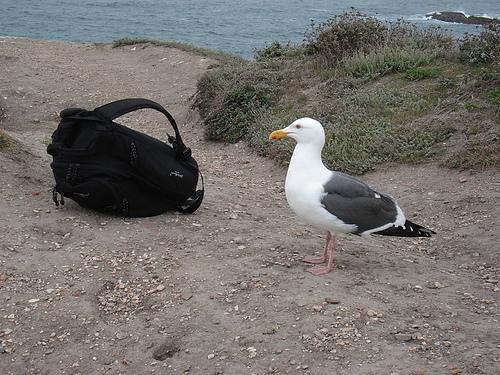How many birds are shown?
Quick response, please. 1. What do the feet of this particular birds have that others do not?
Short answer required. Webbed. What is the seagull standing by?
Answer briefly. Backpack. What would the seagull hope to find in the backpack?
Write a very short answer. Food. Are the birds reflected in water?
Be succinct. No. What type of bird is shown here?
Be succinct. Seagull. What color is the bird's beak?
Be succinct. Yellow. Does the seagull own the backpack?
Quick response, please. No. 